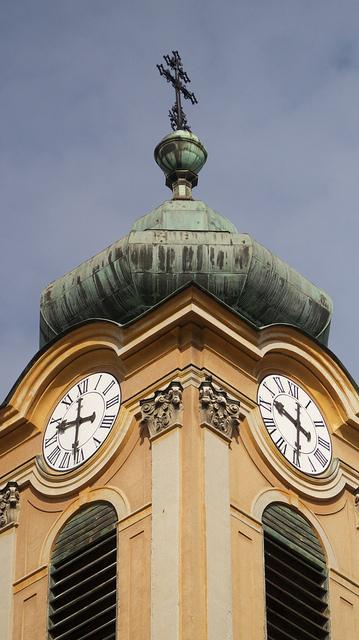How many clocks on the building?
Answer briefly. 2. What religion does the cross on top represent?
Quick response, please. Christian. What time is shown?
Answer briefly. 9:30. 